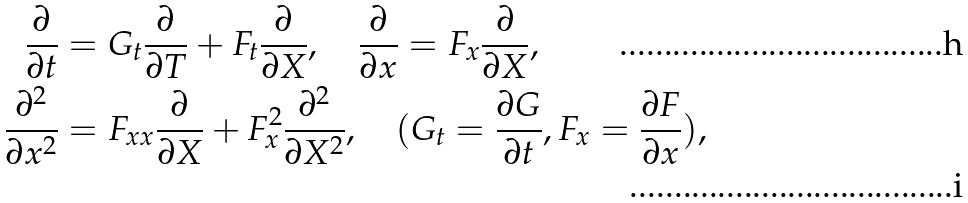<formula> <loc_0><loc_0><loc_500><loc_500>\frac { \partial } { \partial t } & = G _ { t } \frac { \partial } { \partial T } + F _ { t } \frac { \partial } { \partial X } , \quad \frac { \partial } { \partial x } = F _ { x } \frac { \partial } { \partial X } , \\ \frac { \partial ^ { 2 } } { \partial x ^ { 2 } } & = F _ { x x } \frac { \partial } { \partial X } + F _ { x } ^ { 2 } \frac { \partial ^ { 2 } } { \partial X ^ { 2 } } , \quad ( G _ { t } = \frac { \partial G } { \partial t } , F _ { x } = \frac { \partial F } { \partial x } ) ,</formula> 